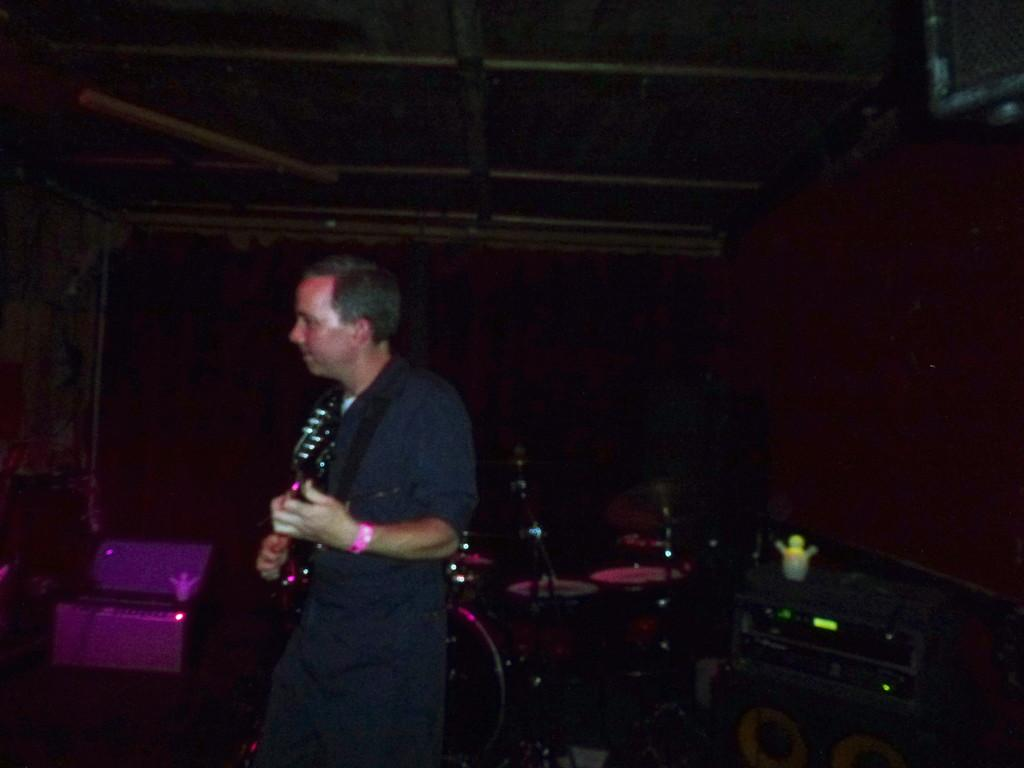What is the main subject of the image? The main subject of the image is a man standing. What is the man wearing in the image? The man is wearing clothes in the image. What object is the man holding in his hand? The man is holding a guitar in his hand. What other objects are present in the image? There are musical instruments in the image. How would you describe the background of the image? The background of the image is dark. Can you see a house in the background of the image? No, there is no house visible in the image. Are there any cherries on the guitar in the image? No, there are no cherries present in the image. 